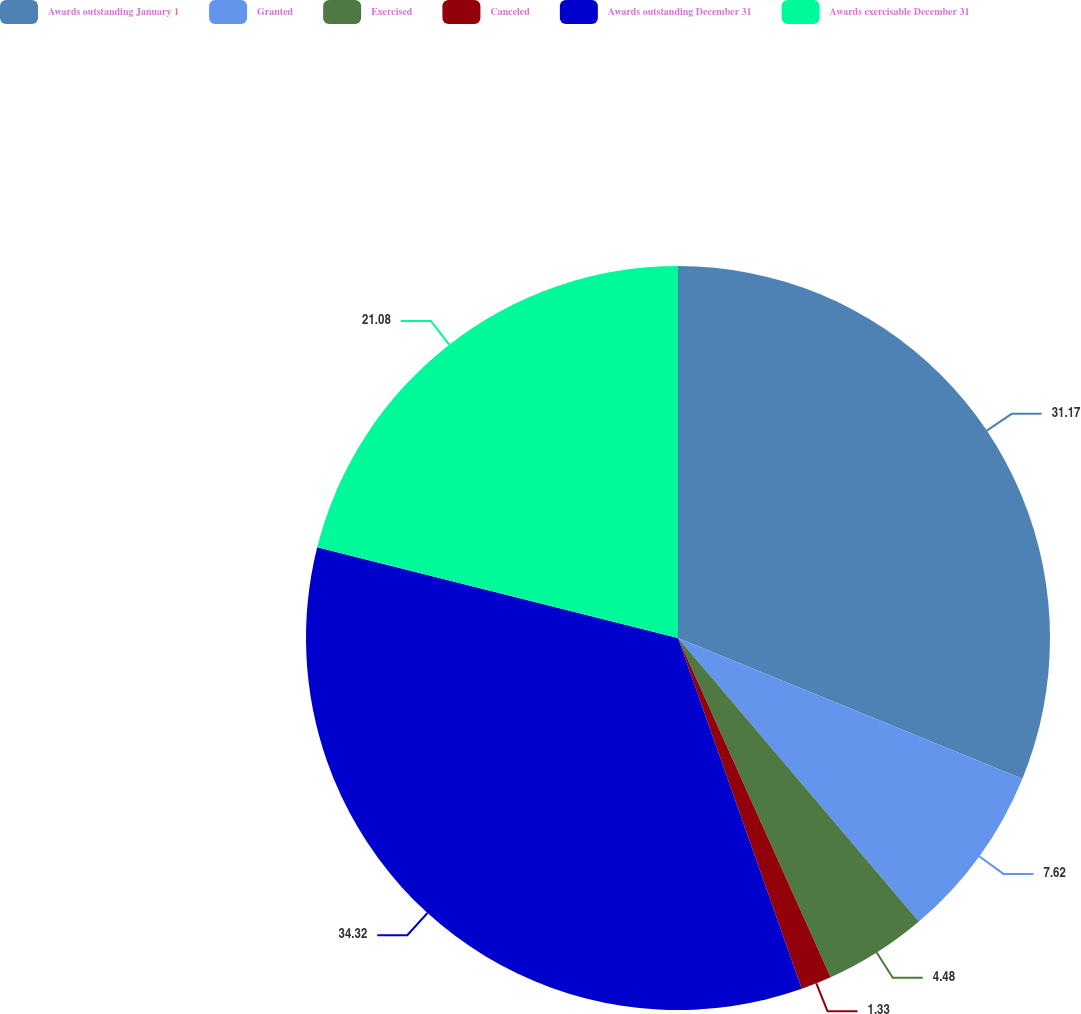<chart> <loc_0><loc_0><loc_500><loc_500><pie_chart><fcel>Awards outstanding January 1<fcel>Granted<fcel>Exercised<fcel>Canceled<fcel>Awards outstanding December 31<fcel>Awards exercisable December 31<nl><fcel>31.17%<fcel>7.62%<fcel>4.48%<fcel>1.33%<fcel>34.32%<fcel>21.08%<nl></chart> 